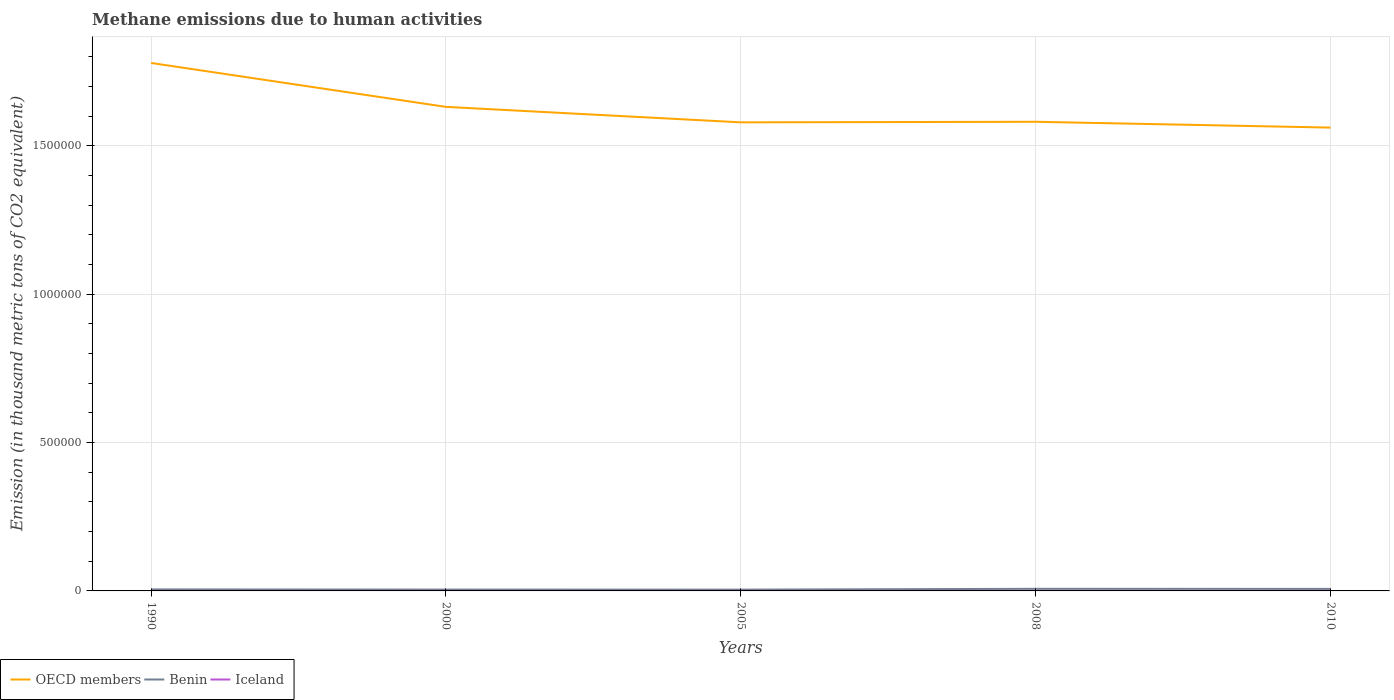How many different coloured lines are there?
Offer a very short reply. 3. Across all years, what is the maximum amount of methane emitted in Iceland?
Offer a terse response. 335.9. What is the total amount of methane emitted in OECD members in the graph?
Provide a succinct answer. 1.48e+05. What is the difference between the highest and the second highest amount of methane emitted in Benin?
Provide a short and direct response. 2709.3. What is the difference between the highest and the lowest amount of methane emitted in Benin?
Your answer should be compact. 2. Is the amount of methane emitted in OECD members strictly greater than the amount of methane emitted in Benin over the years?
Your response must be concise. No. How many years are there in the graph?
Provide a short and direct response. 5. Are the values on the major ticks of Y-axis written in scientific E-notation?
Provide a succinct answer. No. Does the graph contain any zero values?
Ensure brevity in your answer.  No. Where does the legend appear in the graph?
Give a very brief answer. Bottom left. How are the legend labels stacked?
Give a very brief answer. Horizontal. What is the title of the graph?
Give a very brief answer. Methane emissions due to human activities. Does "United Kingdom" appear as one of the legend labels in the graph?
Keep it short and to the point. No. What is the label or title of the X-axis?
Offer a terse response. Years. What is the label or title of the Y-axis?
Keep it short and to the point. Emission (in thousand metric tons of CO2 equivalent). What is the Emission (in thousand metric tons of CO2 equivalent) in OECD members in 1990?
Offer a very short reply. 1.78e+06. What is the Emission (in thousand metric tons of CO2 equivalent) in Benin in 1990?
Provide a short and direct response. 5119.5. What is the Emission (in thousand metric tons of CO2 equivalent) of Iceland in 1990?
Your answer should be compact. 341.7. What is the Emission (in thousand metric tons of CO2 equivalent) of OECD members in 2000?
Offer a terse response. 1.63e+06. What is the Emission (in thousand metric tons of CO2 equivalent) of Benin in 2000?
Give a very brief answer. 4503.8. What is the Emission (in thousand metric tons of CO2 equivalent) in Iceland in 2000?
Offer a very short reply. 336.5. What is the Emission (in thousand metric tons of CO2 equivalent) of OECD members in 2005?
Provide a short and direct response. 1.58e+06. What is the Emission (in thousand metric tons of CO2 equivalent) of Benin in 2005?
Ensure brevity in your answer.  4377.3. What is the Emission (in thousand metric tons of CO2 equivalent) in Iceland in 2005?
Keep it short and to the point. 335.9. What is the Emission (in thousand metric tons of CO2 equivalent) of OECD members in 2008?
Provide a succinct answer. 1.58e+06. What is the Emission (in thousand metric tons of CO2 equivalent) of Benin in 2008?
Your answer should be compact. 7086.6. What is the Emission (in thousand metric tons of CO2 equivalent) in Iceland in 2008?
Provide a succinct answer. 367.2. What is the Emission (in thousand metric tons of CO2 equivalent) of OECD members in 2010?
Your answer should be very brief. 1.56e+06. What is the Emission (in thousand metric tons of CO2 equivalent) in Benin in 2010?
Give a very brief answer. 6845.6. What is the Emission (in thousand metric tons of CO2 equivalent) in Iceland in 2010?
Offer a very short reply. 383.3. Across all years, what is the maximum Emission (in thousand metric tons of CO2 equivalent) in OECD members?
Your answer should be very brief. 1.78e+06. Across all years, what is the maximum Emission (in thousand metric tons of CO2 equivalent) in Benin?
Offer a terse response. 7086.6. Across all years, what is the maximum Emission (in thousand metric tons of CO2 equivalent) of Iceland?
Ensure brevity in your answer.  383.3. Across all years, what is the minimum Emission (in thousand metric tons of CO2 equivalent) of OECD members?
Ensure brevity in your answer.  1.56e+06. Across all years, what is the minimum Emission (in thousand metric tons of CO2 equivalent) of Benin?
Ensure brevity in your answer.  4377.3. Across all years, what is the minimum Emission (in thousand metric tons of CO2 equivalent) of Iceland?
Make the answer very short. 335.9. What is the total Emission (in thousand metric tons of CO2 equivalent) of OECD members in the graph?
Give a very brief answer. 8.13e+06. What is the total Emission (in thousand metric tons of CO2 equivalent) of Benin in the graph?
Make the answer very short. 2.79e+04. What is the total Emission (in thousand metric tons of CO2 equivalent) in Iceland in the graph?
Ensure brevity in your answer.  1764.6. What is the difference between the Emission (in thousand metric tons of CO2 equivalent) in OECD members in 1990 and that in 2000?
Give a very brief answer. 1.48e+05. What is the difference between the Emission (in thousand metric tons of CO2 equivalent) of Benin in 1990 and that in 2000?
Your answer should be compact. 615.7. What is the difference between the Emission (in thousand metric tons of CO2 equivalent) of OECD members in 1990 and that in 2005?
Ensure brevity in your answer.  2.00e+05. What is the difference between the Emission (in thousand metric tons of CO2 equivalent) of Benin in 1990 and that in 2005?
Ensure brevity in your answer.  742.2. What is the difference between the Emission (in thousand metric tons of CO2 equivalent) of OECD members in 1990 and that in 2008?
Your answer should be compact. 1.98e+05. What is the difference between the Emission (in thousand metric tons of CO2 equivalent) of Benin in 1990 and that in 2008?
Your answer should be compact. -1967.1. What is the difference between the Emission (in thousand metric tons of CO2 equivalent) in Iceland in 1990 and that in 2008?
Give a very brief answer. -25.5. What is the difference between the Emission (in thousand metric tons of CO2 equivalent) in OECD members in 1990 and that in 2010?
Keep it short and to the point. 2.18e+05. What is the difference between the Emission (in thousand metric tons of CO2 equivalent) of Benin in 1990 and that in 2010?
Offer a terse response. -1726.1. What is the difference between the Emission (in thousand metric tons of CO2 equivalent) in Iceland in 1990 and that in 2010?
Keep it short and to the point. -41.6. What is the difference between the Emission (in thousand metric tons of CO2 equivalent) of OECD members in 2000 and that in 2005?
Ensure brevity in your answer.  5.21e+04. What is the difference between the Emission (in thousand metric tons of CO2 equivalent) in Benin in 2000 and that in 2005?
Your response must be concise. 126.5. What is the difference between the Emission (in thousand metric tons of CO2 equivalent) of Iceland in 2000 and that in 2005?
Ensure brevity in your answer.  0.6. What is the difference between the Emission (in thousand metric tons of CO2 equivalent) in OECD members in 2000 and that in 2008?
Give a very brief answer. 5.02e+04. What is the difference between the Emission (in thousand metric tons of CO2 equivalent) in Benin in 2000 and that in 2008?
Your response must be concise. -2582.8. What is the difference between the Emission (in thousand metric tons of CO2 equivalent) of Iceland in 2000 and that in 2008?
Provide a succinct answer. -30.7. What is the difference between the Emission (in thousand metric tons of CO2 equivalent) in OECD members in 2000 and that in 2010?
Your answer should be compact. 6.98e+04. What is the difference between the Emission (in thousand metric tons of CO2 equivalent) of Benin in 2000 and that in 2010?
Give a very brief answer. -2341.8. What is the difference between the Emission (in thousand metric tons of CO2 equivalent) of Iceland in 2000 and that in 2010?
Give a very brief answer. -46.8. What is the difference between the Emission (in thousand metric tons of CO2 equivalent) of OECD members in 2005 and that in 2008?
Ensure brevity in your answer.  -1871.6. What is the difference between the Emission (in thousand metric tons of CO2 equivalent) of Benin in 2005 and that in 2008?
Ensure brevity in your answer.  -2709.3. What is the difference between the Emission (in thousand metric tons of CO2 equivalent) in Iceland in 2005 and that in 2008?
Provide a succinct answer. -31.3. What is the difference between the Emission (in thousand metric tons of CO2 equivalent) of OECD members in 2005 and that in 2010?
Offer a terse response. 1.77e+04. What is the difference between the Emission (in thousand metric tons of CO2 equivalent) of Benin in 2005 and that in 2010?
Offer a terse response. -2468.3. What is the difference between the Emission (in thousand metric tons of CO2 equivalent) of Iceland in 2005 and that in 2010?
Offer a terse response. -47.4. What is the difference between the Emission (in thousand metric tons of CO2 equivalent) in OECD members in 2008 and that in 2010?
Keep it short and to the point. 1.96e+04. What is the difference between the Emission (in thousand metric tons of CO2 equivalent) of Benin in 2008 and that in 2010?
Keep it short and to the point. 241. What is the difference between the Emission (in thousand metric tons of CO2 equivalent) of Iceland in 2008 and that in 2010?
Offer a very short reply. -16.1. What is the difference between the Emission (in thousand metric tons of CO2 equivalent) in OECD members in 1990 and the Emission (in thousand metric tons of CO2 equivalent) in Benin in 2000?
Offer a terse response. 1.77e+06. What is the difference between the Emission (in thousand metric tons of CO2 equivalent) in OECD members in 1990 and the Emission (in thousand metric tons of CO2 equivalent) in Iceland in 2000?
Provide a short and direct response. 1.78e+06. What is the difference between the Emission (in thousand metric tons of CO2 equivalent) in Benin in 1990 and the Emission (in thousand metric tons of CO2 equivalent) in Iceland in 2000?
Your response must be concise. 4783. What is the difference between the Emission (in thousand metric tons of CO2 equivalent) in OECD members in 1990 and the Emission (in thousand metric tons of CO2 equivalent) in Benin in 2005?
Give a very brief answer. 1.78e+06. What is the difference between the Emission (in thousand metric tons of CO2 equivalent) in OECD members in 1990 and the Emission (in thousand metric tons of CO2 equivalent) in Iceland in 2005?
Provide a short and direct response. 1.78e+06. What is the difference between the Emission (in thousand metric tons of CO2 equivalent) in Benin in 1990 and the Emission (in thousand metric tons of CO2 equivalent) in Iceland in 2005?
Make the answer very short. 4783.6. What is the difference between the Emission (in thousand metric tons of CO2 equivalent) of OECD members in 1990 and the Emission (in thousand metric tons of CO2 equivalent) of Benin in 2008?
Provide a short and direct response. 1.77e+06. What is the difference between the Emission (in thousand metric tons of CO2 equivalent) of OECD members in 1990 and the Emission (in thousand metric tons of CO2 equivalent) of Iceland in 2008?
Offer a very short reply. 1.78e+06. What is the difference between the Emission (in thousand metric tons of CO2 equivalent) in Benin in 1990 and the Emission (in thousand metric tons of CO2 equivalent) in Iceland in 2008?
Provide a succinct answer. 4752.3. What is the difference between the Emission (in thousand metric tons of CO2 equivalent) in OECD members in 1990 and the Emission (in thousand metric tons of CO2 equivalent) in Benin in 2010?
Provide a short and direct response. 1.77e+06. What is the difference between the Emission (in thousand metric tons of CO2 equivalent) of OECD members in 1990 and the Emission (in thousand metric tons of CO2 equivalent) of Iceland in 2010?
Provide a short and direct response. 1.78e+06. What is the difference between the Emission (in thousand metric tons of CO2 equivalent) of Benin in 1990 and the Emission (in thousand metric tons of CO2 equivalent) of Iceland in 2010?
Make the answer very short. 4736.2. What is the difference between the Emission (in thousand metric tons of CO2 equivalent) of OECD members in 2000 and the Emission (in thousand metric tons of CO2 equivalent) of Benin in 2005?
Make the answer very short. 1.63e+06. What is the difference between the Emission (in thousand metric tons of CO2 equivalent) of OECD members in 2000 and the Emission (in thousand metric tons of CO2 equivalent) of Iceland in 2005?
Ensure brevity in your answer.  1.63e+06. What is the difference between the Emission (in thousand metric tons of CO2 equivalent) in Benin in 2000 and the Emission (in thousand metric tons of CO2 equivalent) in Iceland in 2005?
Make the answer very short. 4167.9. What is the difference between the Emission (in thousand metric tons of CO2 equivalent) in OECD members in 2000 and the Emission (in thousand metric tons of CO2 equivalent) in Benin in 2008?
Give a very brief answer. 1.62e+06. What is the difference between the Emission (in thousand metric tons of CO2 equivalent) of OECD members in 2000 and the Emission (in thousand metric tons of CO2 equivalent) of Iceland in 2008?
Make the answer very short. 1.63e+06. What is the difference between the Emission (in thousand metric tons of CO2 equivalent) in Benin in 2000 and the Emission (in thousand metric tons of CO2 equivalent) in Iceland in 2008?
Give a very brief answer. 4136.6. What is the difference between the Emission (in thousand metric tons of CO2 equivalent) of OECD members in 2000 and the Emission (in thousand metric tons of CO2 equivalent) of Benin in 2010?
Your response must be concise. 1.62e+06. What is the difference between the Emission (in thousand metric tons of CO2 equivalent) in OECD members in 2000 and the Emission (in thousand metric tons of CO2 equivalent) in Iceland in 2010?
Provide a short and direct response. 1.63e+06. What is the difference between the Emission (in thousand metric tons of CO2 equivalent) of Benin in 2000 and the Emission (in thousand metric tons of CO2 equivalent) of Iceland in 2010?
Offer a terse response. 4120.5. What is the difference between the Emission (in thousand metric tons of CO2 equivalent) of OECD members in 2005 and the Emission (in thousand metric tons of CO2 equivalent) of Benin in 2008?
Your answer should be very brief. 1.57e+06. What is the difference between the Emission (in thousand metric tons of CO2 equivalent) of OECD members in 2005 and the Emission (in thousand metric tons of CO2 equivalent) of Iceland in 2008?
Offer a terse response. 1.58e+06. What is the difference between the Emission (in thousand metric tons of CO2 equivalent) of Benin in 2005 and the Emission (in thousand metric tons of CO2 equivalent) of Iceland in 2008?
Your answer should be compact. 4010.1. What is the difference between the Emission (in thousand metric tons of CO2 equivalent) of OECD members in 2005 and the Emission (in thousand metric tons of CO2 equivalent) of Benin in 2010?
Your response must be concise. 1.57e+06. What is the difference between the Emission (in thousand metric tons of CO2 equivalent) of OECD members in 2005 and the Emission (in thousand metric tons of CO2 equivalent) of Iceland in 2010?
Keep it short and to the point. 1.58e+06. What is the difference between the Emission (in thousand metric tons of CO2 equivalent) of Benin in 2005 and the Emission (in thousand metric tons of CO2 equivalent) of Iceland in 2010?
Provide a short and direct response. 3994. What is the difference between the Emission (in thousand metric tons of CO2 equivalent) of OECD members in 2008 and the Emission (in thousand metric tons of CO2 equivalent) of Benin in 2010?
Keep it short and to the point. 1.57e+06. What is the difference between the Emission (in thousand metric tons of CO2 equivalent) in OECD members in 2008 and the Emission (in thousand metric tons of CO2 equivalent) in Iceland in 2010?
Make the answer very short. 1.58e+06. What is the difference between the Emission (in thousand metric tons of CO2 equivalent) in Benin in 2008 and the Emission (in thousand metric tons of CO2 equivalent) in Iceland in 2010?
Offer a very short reply. 6703.3. What is the average Emission (in thousand metric tons of CO2 equivalent) in OECD members per year?
Ensure brevity in your answer.  1.63e+06. What is the average Emission (in thousand metric tons of CO2 equivalent) in Benin per year?
Your answer should be very brief. 5586.56. What is the average Emission (in thousand metric tons of CO2 equivalent) in Iceland per year?
Provide a short and direct response. 352.92. In the year 1990, what is the difference between the Emission (in thousand metric tons of CO2 equivalent) in OECD members and Emission (in thousand metric tons of CO2 equivalent) in Benin?
Ensure brevity in your answer.  1.77e+06. In the year 1990, what is the difference between the Emission (in thousand metric tons of CO2 equivalent) in OECD members and Emission (in thousand metric tons of CO2 equivalent) in Iceland?
Your response must be concise. 1.78e+06. In the year 1990, what is the difference between the Emission (in thousand metric tons of CO2 equivalent) in Benin and Emission (in thousand metric tons of CO2 equivalent) in Iceland?
Give a very brief answer. 4777.8. In the year 2000, what is the difference between the Emission (in thousand metric tons of CO2 equivalent) in OECD members and Emission (in thousand metric tons of CO2 equivalent) in Benin?
Provide a short and direct response. 1.63e+06. In the year 2000, what is the difference between the Emission (in thousand metric tons of CO2 equivalent) in OECD members and Emission (in thousand metric tons of CO2 equivalent) in Iceland?
Ensure brevity in your answer.  1.63e+06. In the year 2000, what is the difference between the Emission (in thousand metric tons of CO2 equivalent) in Benin and Emission (in thousand metric tons of CO2 equivalent) in Iceland?
Your response must be concise. 4167.3. In the year 2005, what is the difference between the Emission (in thousand metric tons of CO2 equivalent) in OECD members and Emission (in thousand metric tons of CO2 equivalent) in Benin?
Provide a succinct answer. 1.57e+06. In the year 2005, what is the difference between the Emission (in thousand metric tons of CO2 equivalent) in OECD members and Emission (in thousand metric tons of CO2 equivalent) in Iceland?
Offer a terse response. 1.58e+06. In the year 2005, what is the difference between the Emission (in thousand metric tons of CO2 equivalent) of Benin and Emission (in thousand metric tons of CO2 equivalent) of Iceland?
Offer a very short reply. 4041.4. In the year 2008, what is the difference between the Emission (in thousand metric tons of CO2 equivalent) in OECD members and Emission (in thousand metric tons of CO2 equivalent) in Benin?
Your answer should be very brief. 1.57e+06. In the year 2008, what is the difference between the Emission (in thousand metric tons of CO2 equivalent) in OECD members and Emission (in thousand metric tons of CO2 equivalent) in Iceland?
Ensure brevity in your answer.  1.58e+06. In the year 2008, what is the difference between the Emission (in thousand metric tons of CO2 equivalent) of Benin and Emission (in thousand metric tons of CO2 equivalent) of Iceland?
Make the answer very short. 6719.4. In the year 2010, what is the difference between the Emission (in thousand metric tons of CO2 equivalent) of OECD members and Emission (in thousand metric tons of CO2 equivalent) of Benin?
Offer a terse response. 1.55e+06. In the year 2010, what is the difference between the Emission (in thousand metric tons of CO2 equivalent) of OECD members and Emission (in thousand metric tons of CO2 equivalent) of Iceland?
Offer a terse response. 1.56e+06. In the year 2010, what is the difference between the Emission (in thousand metric tons of CO2 equivalent) in Benin and Emission (in thousand metric tons of CO2 equivalent) in Iceland?
Your answer should be very brief. 6462.3. What is the ratio of the Emission (in thousand metric tons of CO2 equivalent) in OECD members in 1990 to that in 2000?
Make the answer very short. 1.09. What is the ratio of the Emission (in thousand metric tons of CO2 equivalent) in Benin in 1990 to that in 2000?
Offer a very short reply. 1.14. What is the ratio of the Emission (in thousand metric tons of CO2 equivalent) of Iceland in 1990 to that in 2000?
Offer a very short reply. 1.02. What is the ratio of the Emission (in thousand metric tons of CO2 equivalent) in OECD members in 1990 to that in 2005?
Provide a short and direct response. 1.13. What is the ratio of the Emission (in thousand metric tons of CO2 equivalent) in Benin in 1990 to that in 2005?
Ensure brevity in your answer.  1.17. What is the ratio of the Emission (in thousand metric tons of CO2 equivalent) in Iceland in 1990 to that in 2005?
Provide a short and direct response. 1.02. What is the ratio of the Emission (in thousand metric tons of CO2 equivalent) of OECD members in 1990 to that in 2008?
Your response must be concise. 1.13. What is the ratio of the Emission (in thousand metric tons of CO2 equivalent) of Benin in 1990 to that in 2008?
Provide a succinct answer. 0.72. What is the ratio of the Emission (in thousand metric tons of CO2 equivalent) in Iceland in 1990 to that in 2008?
Provide a succinct answer. 0.93. What is the ratio of the Emission (in thousand metric tons of CO2 equivalent) in OECD members in 1990 to that in 2010?
Your answer should be compact. 1.14. What is the ratio of the Emission (in thousand metric tons of CO2 equivalent) in Benin in 1990 to that in 2010?
Your response must be concise. 0.75. What is the ratio of the Emission (in thousand metric tons of CO2 equivalent) of Iceland in 1990 to that in 2010?
Provide a succinct answer. 0.89. What is the ratio of the Emission (in thousand metric tons of CO2 equivalent) of OECD members in 2000 to that in 2005?
Offer a very short reply. 1.03. What is the ratio of the Emission (in thousand metric tons of CO2 equivalent) of Benin in 2000 to that in 2005?
Make the answer very short. 1.03. What is the ratio of the Emission (in thousand metric tons of CO2 equivalent) in Iceland in 2000 to that in 2005?
Keep it short and to the point. 1. What is the ratio of the Emission (in thousand metric tons of CO2 equivalent) of OECD members in 2000 to that in 2008?
Provide a succinct answer. 1.03. What is the ratio of the Emission (in thousand metric tons of CO2 equivalent) of Benin in 2000 to that in 2008?
Ensure brevity in your answer.  0.64. What is the ratio of the Emission (in thousand metric tons of CO2 equivalent) in Iceland in 2000 to that in 2008?
Offer a very short reply. 0.92. What is the ratio of the Emission (in thousand metric tons of CO2 equivalent) of OECD members in 2000 to that in 2010?
Ensure brevity in your answer.  1.04. What is the ratio of the Emission (in thousand metric tons of CO2 equivalent) of Benin in 2000 to that in 2010?
Give a very brief answer. 0.66. What is the ratio of the Emission (in thousand metric tons of CO2 equivalent) of Iceland in 2000 to that in 2010?
Provide a succinct answer. 0.88. What is the ratio of the Emission (in thousand metric tons of CO2 equivalent) in Benin in 2005 to that in 2008?
Give a very brief answer. 0.62. What is the ratio of the Emission (in thousand metric tons of CO2 equivalent) of Iceland in 2005 to that in 2008?
Ensure brevity in your answer.  0.91. What is the ratio of the Emission (in thousand metric tons of CO2 equivalent) in OECD members in 2005 to that in 2010?
Keep it short and to the point. 1.01. What is the ratio of the Emission (in thousand metric tons of CO2 equivalent) in Benin in 2005 to that in 2010?
Offer a terse response. 0.64. What is the ratio of the Emission (in thousand metric tons of CO2 equivalent) in Iceland in 2005 to that in 2010?
Your response must be concise. 0.88. What is the ratio of the Emission (in thousand metric tons of CO2 equivalent) in OECD members in 2008 to that in 2010?
Your answer should be compact. 1.01. What is the ratio of the Emission (in thousand metric tons of CO2 equivalent) of Benin in 2008 to that in 2010?
Your answer should be very brief. 1.04. What is the ratio of the Emission (in thousand metric tons of CO2 equivalent) in Iceland in 2008 to that in 2010?
Make the answer very short. 0.96. What is the difference between the highest and the second highest Emission (in thousand metric tons of CO2 equivalent) of OECD members?
Your answer should be compact. 1.48e+05. What is the difference between the highest and the second highest Emission (in thousand metric tons of CO2 equivalent) of Benin?
Your answer should be very brief. 241. What is the difference between the highest and the second highest Emission (in thousand metric tons of CO2 equivalent) in Iceland?
Your answer should be compact. 16.1. What is the difference between the highest and the lowest Emission (in thousand metric tons of CO2 equivalent) of OECD members?
Your answer should be very brief. 2.18e+05. What is the difference between the highest and the lowest Emission (in thousand metric tons of CO2 equivalent) in Benin?
Your answer should be very brief. 2709.3. What is the difference between the highest and the lowest Emission (in thousand metric tons of CO2 equivalent) in Iceland?
Provide a short and direct response. 47.4. 